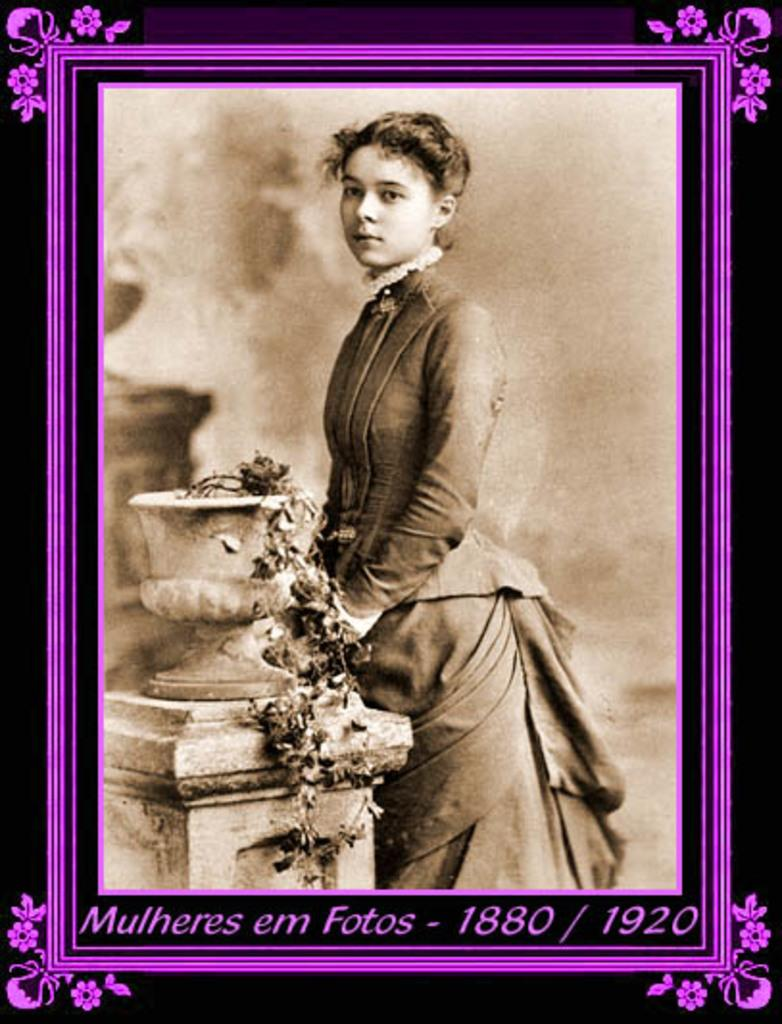What object is present in the image that typically holds a picture? There is a picture frame in the image. What can be seen inside the picture frame? The picture contains a woman. Where is the woman positioned in relation to the pillar? The woman is standing near a pillar. What is on top of the pillar? There is a pot on the pillar. What is inside the pot on the pillar? The pot has a plant in it. How many girls are teaching in the image? There are no girls or teaching activities present in the image. 